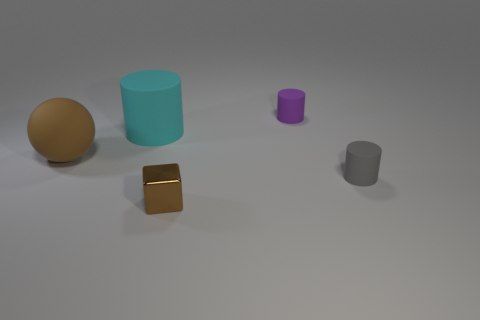Is the number of small brown blocks that are in front of the tiny metal thing the same as the number of tiny gray cylinders?
Offer a very short reply. No. What size is the sphere that is the same color as the small shiny block?
Make the answer very short. Large. Is there a small purple cylinder that has the same material as the cyan cylinder?
Keep it short and to the point. Yes. There is a large thing behind the large brown matte thing; does it have the same shape as the brown object to the left of the brown block?
Give a very brief answer. No. Is there a small green block?
Make the answer very short. No. There is a thing that is the same size as the matte sphere; what color is it?
Provide a succinct answer. Cyan. What number of other big brown objects are the same shape as the big brown matte thing?
Provide a succinct answer. 0. Is the small brown cube on the left side of the small purple cylinder made of the same material as the big cyan cylinder?
Keep it short and to the point. No. What number of balls are either big cyan matte things or small green things?
Give a very brief answer. 0. There is a brown object that is behind the object that is in front of the tiny matte cylinder in front of the small purple matte cylinder; what shape is it?
Give a very brief answer. Sphere. 